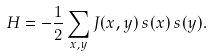<formula> <loc_0><loc_0><loc_500><loc_500>H = - \frac { 1 } { 2 } \sum _ { { x } , { y } } J ( { x } , { y } ) \, s ( { x } ) \, s ( { y } ) .</formula> 